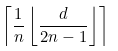<formula> <loc_0><loc_0><loc_500><loc_500>\left \lceil \frac { 1 } { n } \left \lfloor \frac { d } { 2 n - 1 } \right \rfloor \right \rceil</formula> 